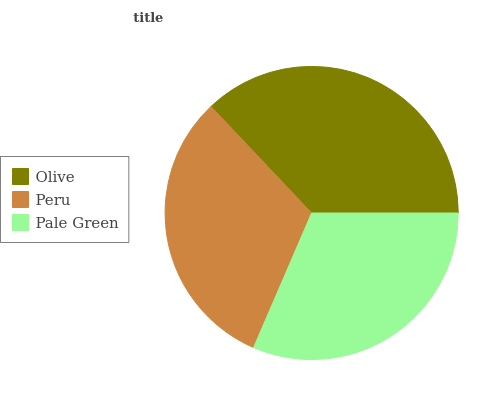Is Peru the minimum?
Answer yes or no. Yes. Is Olive the maximum?
Answer yes or no. Yes. Is Pale Green the minimum?
Answer yes or no. No. Is Pale Green the maximum?
Answer yes or no. No. Is Pale Green greater than Peru?
Answer yes or no. Yes. Is Peru less than Pale Green?
Answer yes or no. Yes. Is Peru greater than Pale Green?
Answer yes or no. No. Is Pale Green less than Peru?
Answer yes or no. No. Is Pale Green the high median?
Answer yes or no. Yes. Is Pale Green the low median?
Answer yes or no. Yes. Is Olive the high median?
Answer yes or no. No. Is Olive the low median?
Answer yes or no. No. 